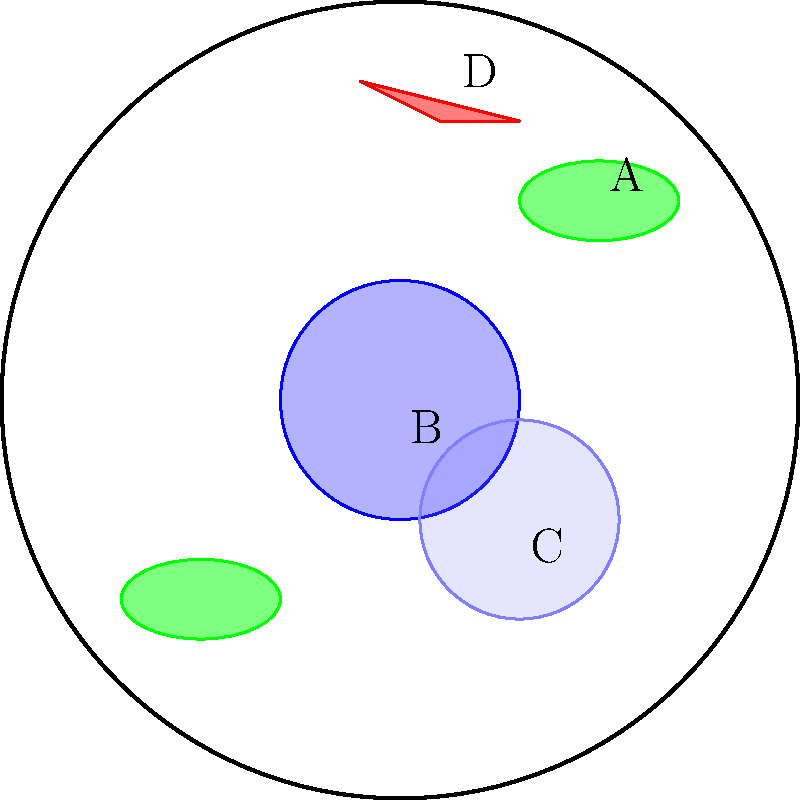In the microscope image of a plant cell above, which labeled structure is responsible for photosynthesis and is crucial for the production of active compounds used in plant-based cosmetics? To answer this question, let's analyze each labeled structure:

1. Structure A: These are oval-shaped green organelles. In plant cells, chloroplasts are the organelles responsible for photosynthesis. They are crucial for producing various compounds used in plant-based cosmetics.

2. Structure B: This is the large, centrally located spherical structure. It resembles the nucleus, which contains genetic material but is not directly involved in photosynthesis.

3. Structure C: This large, light-colored structure is likely the vacuole. While important for cell turgor and storage, it's not the site of photosynthesis.

4. Structure D: This small, red organelle is probably a mitochondrion. It's involved in cellular respiration but not photosynthesis.

Given the question's focus on photosynthesis and active compounds for cosmetics, the correct answer is Structure A, which represents chloroplasts. Chloroplasts are essential for photosynthesis, producing various metabolites and active compounds used in plant-based cosmetic formulations.
Answer: A (Chloroplasts) 